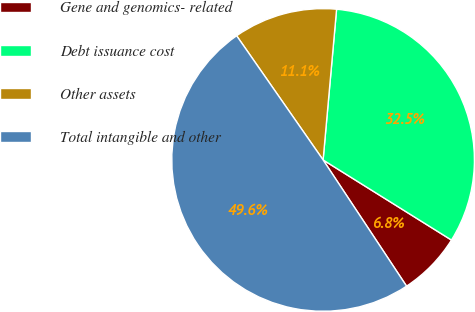Convert chart. <chart><loc_0><loc_0><loc_500><loc_500><pie_chart><fcel>Gene and genomics- related<fcel>Debt issuance cost<fcel>Other assets<fcel>Total intangible and other<nl><fcel>6.82%<fcel>32.46%<fcel>11.1%<fcel>49.62%<nl></chart> 